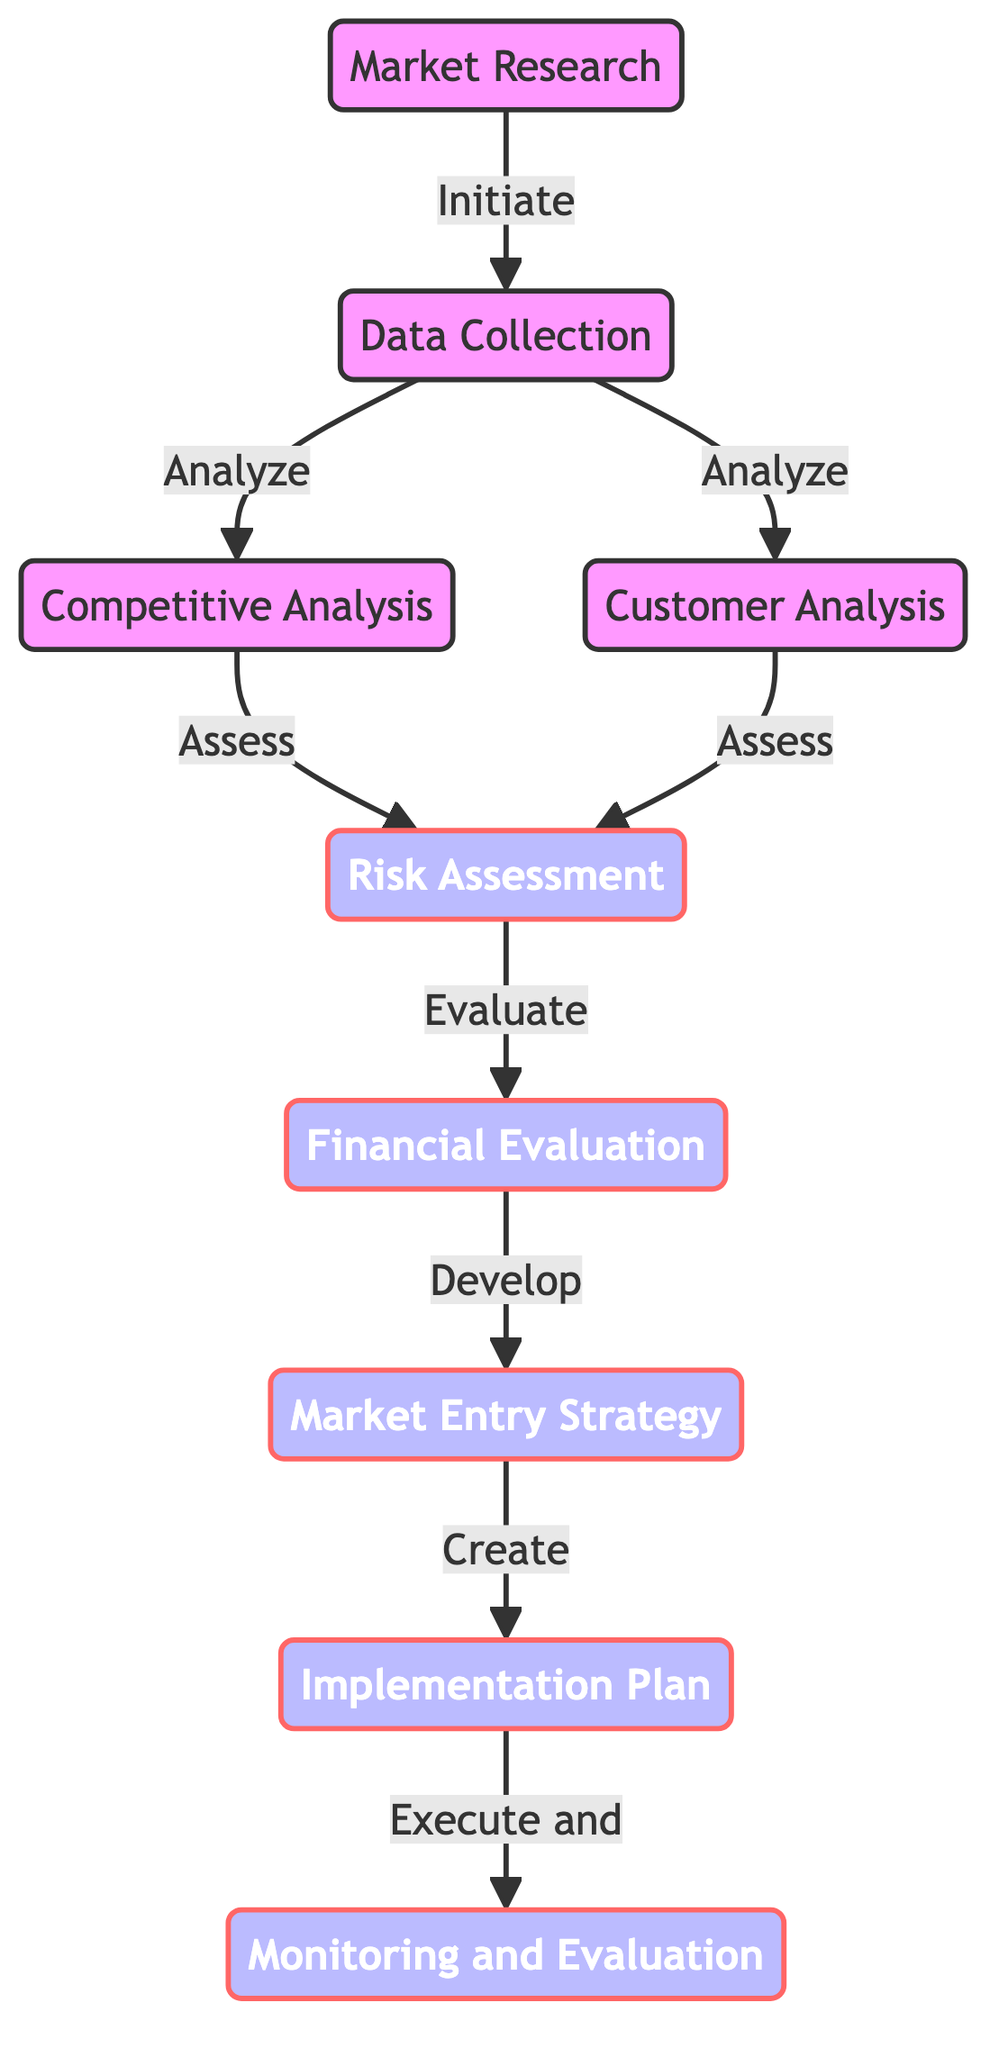What is the first step in the decision-making process? The diagram shows that the first step is "Market Research," indicating it as the starting point for the evaluation process.
Answer: Market Research How many nodes are in this diagram? By counting the listed nodes in the diagram, there are a total of nine distinct nodes representing different steps in the decision-making process.
Answer: 9 What comes after "Risk Assessment"? The flow in the diagram indicates that after completing "Risk Assessment," the next step is "Financial Evaluation," following the arrows that indicate the directional flow of the process.
Answer: Financial Evaluation Which nodes analyze data collected? The diagram shows two nodes, "Competitive Analysis" and "Customer Analysis," that both follow "Data Collection" and involve analyzing the collected data.
Answer: Competitive Analysis, Customer Analysis Which step leads directly to "Monitoring and Evaluation"? According to the diagram, the "Implementation Plan" is the step that leads directly into the final stage, which is "Monitoring and Evaluation," as represented by the arrow pointing from one to the other.
Answer: Implementation Plan What are the two assessment processes in this evaluation? The diagram indicates that both "Competitive Analysis" and "Customer Analysis" are processes that lead to the "Risk Assessment," suggesting they are central to the evaluation stage.
Answer: Competitive Analysis, Customer Analysis What is the last step in the decision-making process? The final node in the diagram sequence is "Monitoring and Evaluation," which is the endpoint of the directed graph and represents the conclusion of the decision-making process.
Answer: Monitoring and Evaluation How many edges connect "Data Collection" to other nodes? By examining the diagram, there are two edges originating from "Data Collection" that connect it to both "Competitive Analysis" and "Customer Analysis".
Answer: 2 What does "Financial Evaluation" lead to? In the flowchart, "Financial Evaluation" leads directly to the next step called "Market Entry Strategy," as shown by the arrow connecting these two nodes.
Answer: Market Entry Strategy 